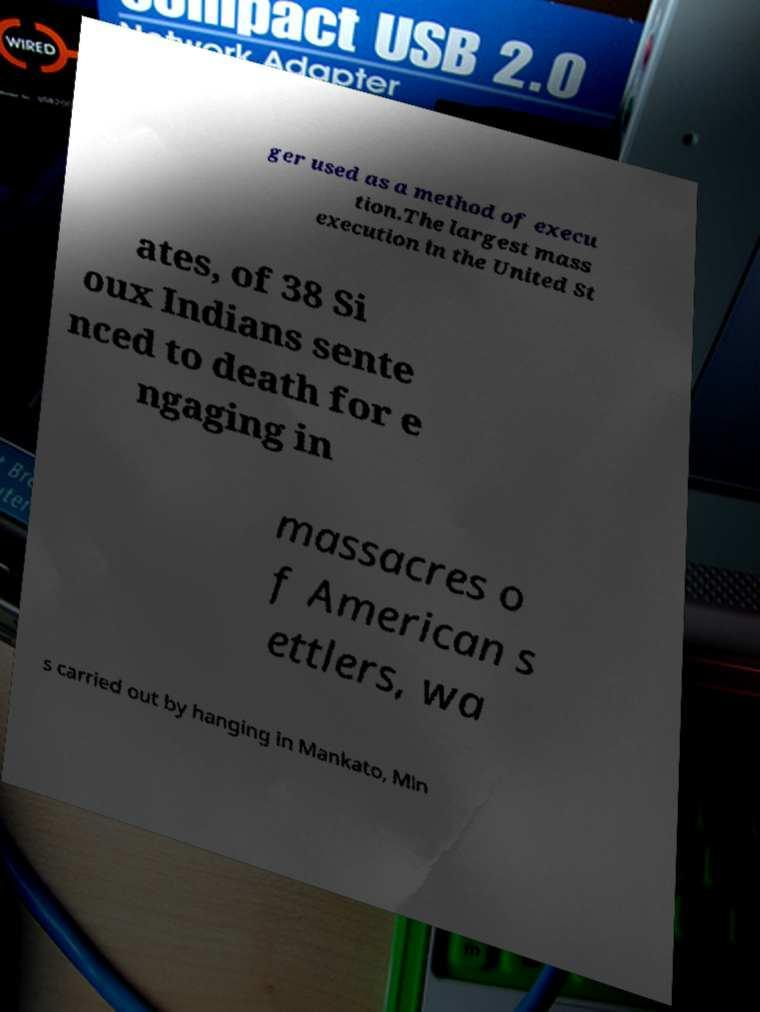There's text embedded in this image that I need extracted. Can you transcribe it verbatim? ger used as a method of execu tion.The largest mass execution in the United St ates, of 38 Si oux Indians sente nced to death for e ngaging in massacres o f American s ettlers, wa s carried out by hanging in Mankato, Min 